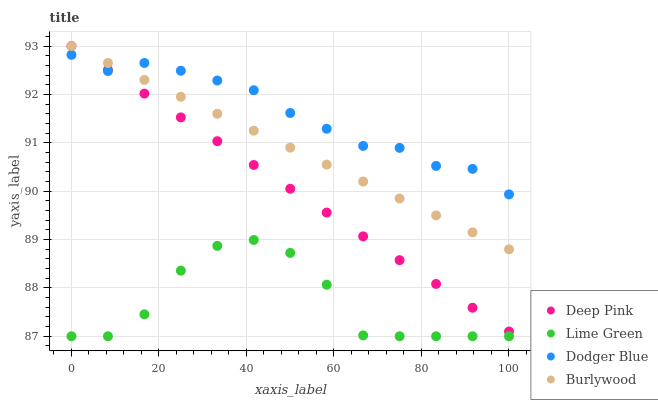Does Lime Green have the minimum area under the curve?
Answer yes or no. Yes. Does Dodger Blue have the maximum area under the curve?
Answer yes or no. Yes. Does Deep Pink have the minimum area under the curve?
Answer yes or no. No. Does Deep Pink have the maximum area under the curve?
Answer yes or no. No. Is Deep Pink the smoothest?
Answer yes or no. Yes. Is Lime Green the roughest?
Answer yes or no. Yes. Is Dodger Blue the smoothest?
Answer yes or no. No. Is Dodger Blue the roughest?
Answer yes or no. No. Does Lime Green have the lowest value?
Answer yes or no. Yes. Does Deep Pink have the lowest value?
Answer yes or no. No. Does Deep Pink have the highest value?
Answer yes or no. Yes. Does Dodger Blue have the highest value?
Answer yes or no. No. Is Lime Green less than Dodger Blue?
Answer yes or no. Yes. Is Burlywood greater than Lime Green?
Answer yes or no. Yes. Does Burlywood intersect Deep Pink?
Answer yes or no. Yes. Is Burlywood less than Deep Pink?
Answer yes or no. No. Is Burlywood greater than Deep Pink?
Answer yes or no. No. Does Lime Green intersect Dodger Blue?
Answer yes or no. No. 